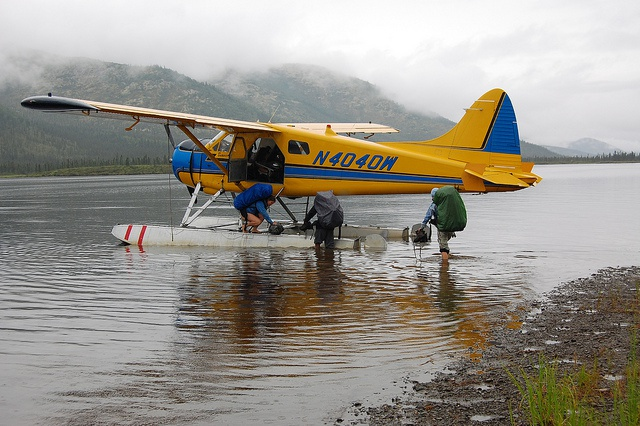Describe the objects in this image and their specific colors. I can see airplane in white, olive, orange, black, and gray tones, people in white, black, gray, darkgreen, and darkgray tones, backpack in white, black, darkgreen, and teal tones, backpack in white, black, and gray tones, and people in white, black, maroon, navy, and brown tones in this image. 